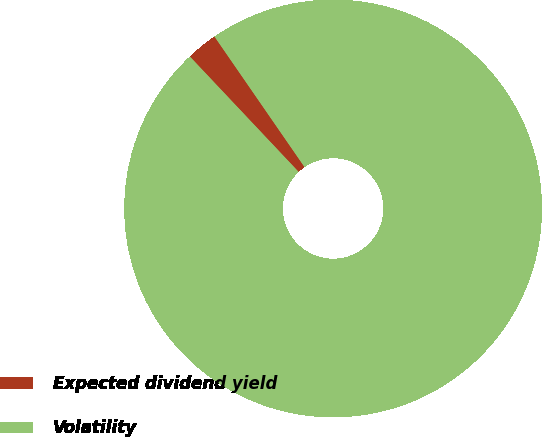<chart> <loc_0><loc_0><loc_500><loc_500><pie_chart><fcel>Expected dividend yield<fcel>Volatility<nl><fcel>2.42%<fcel>97.58%<nl></chart> 